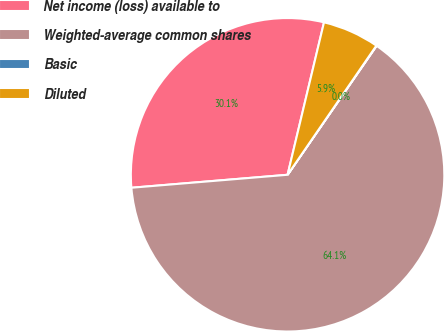<chart> <loc_0><loc_0><loc_500><loc_500><pie_chart><fcel>Net income (loss) available to<fcel>Weighted-average common shares<fcel>Basic<fcel>Diluted<nl><fcel>30.05%<fcel>64.06%<fcel>0.03%<fcel>5.85%<nl></chart> 